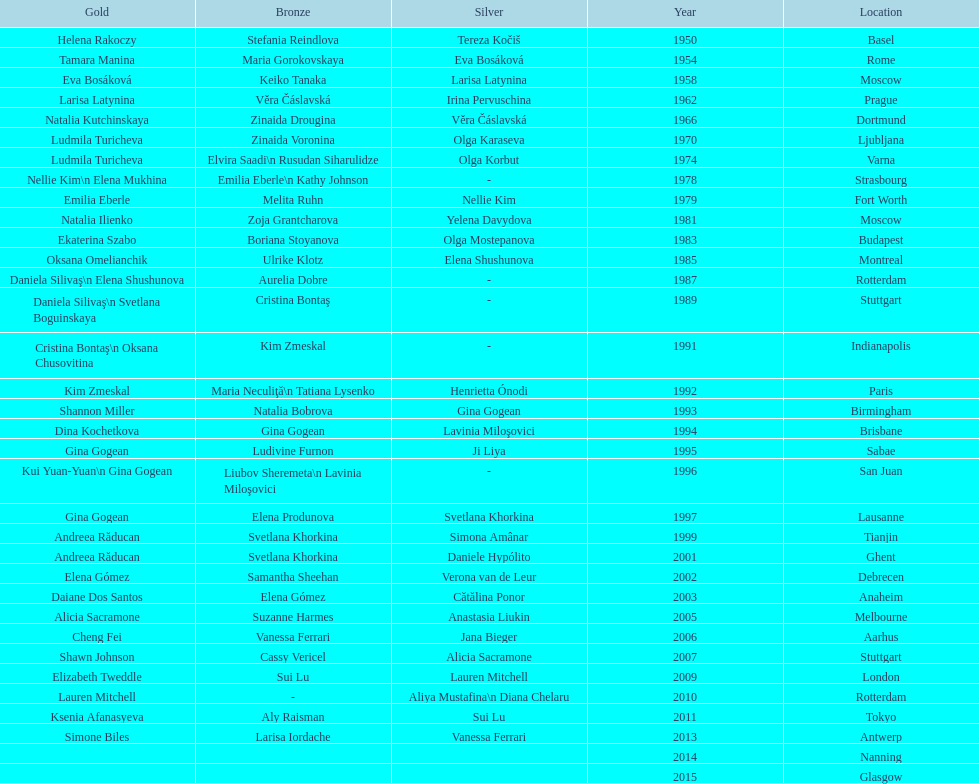What is the total number of russian gymnasts that have won silver. 8. 